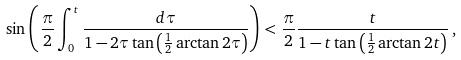<formula> <loc_0><loc_0><loc_500><loc_500>\sin \left ( \frac { \pi } { 2 } \int _ { 0 } ^ { t } \frac { d \tau } { 1 - { 2 \tau } \tan \left ( \frac { 1 } { 2 } \arctan 2 \tau \right ) } \right ) < \frac { \pi } { 2 } \frac { t } { 1 - { t } \tan \left ( \frac { 1 } { 2 } \arctan 2 t \right ) } \, ,</formula> 